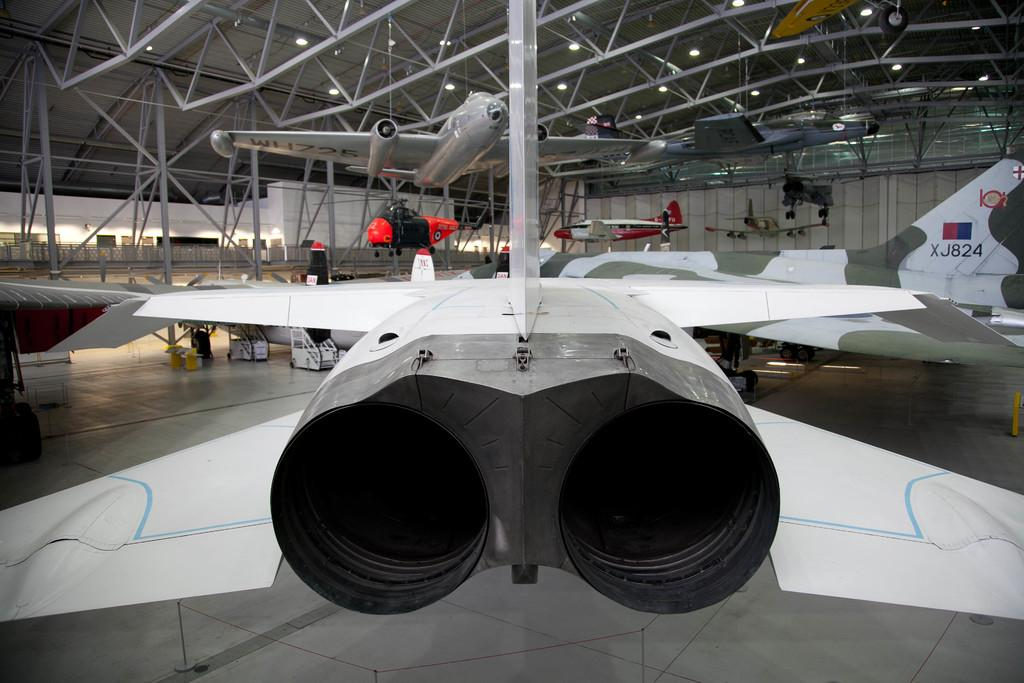<image>
Give a short and clear explanation of the subsequent image. Various military airplanes are on display in a hanger, including one with call letters XJ824.one 